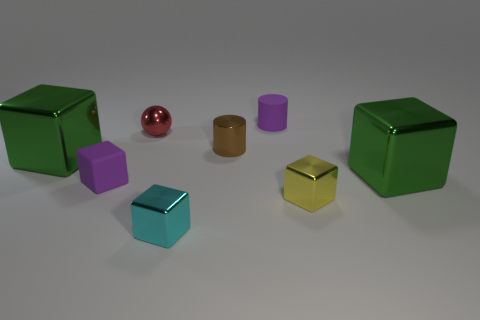Subtract 1 blocks. How many blocks are left? 4 Subtract all cyan blocks. How many blocks are left? 4 Subtract all small purple blocks. How many blocks are left? 4 Subtract all brown cubes. Subtract all green spheres. How many cubes are left? 5 Add 1 tiny purple rubber things. How many objects exist? 9 Subtract all cubes. How many objects are left? 3 Add 8 red metallic spheres. How many red metallic spheres are left? 9 Add 6 gray matte balls. How many gray matte balls exist? 6 Subtract 2 green blocks. How many objects are left? 6 Subtract all tiny purple cylinders. Subtract all large blocks. How many objects are left? 5 